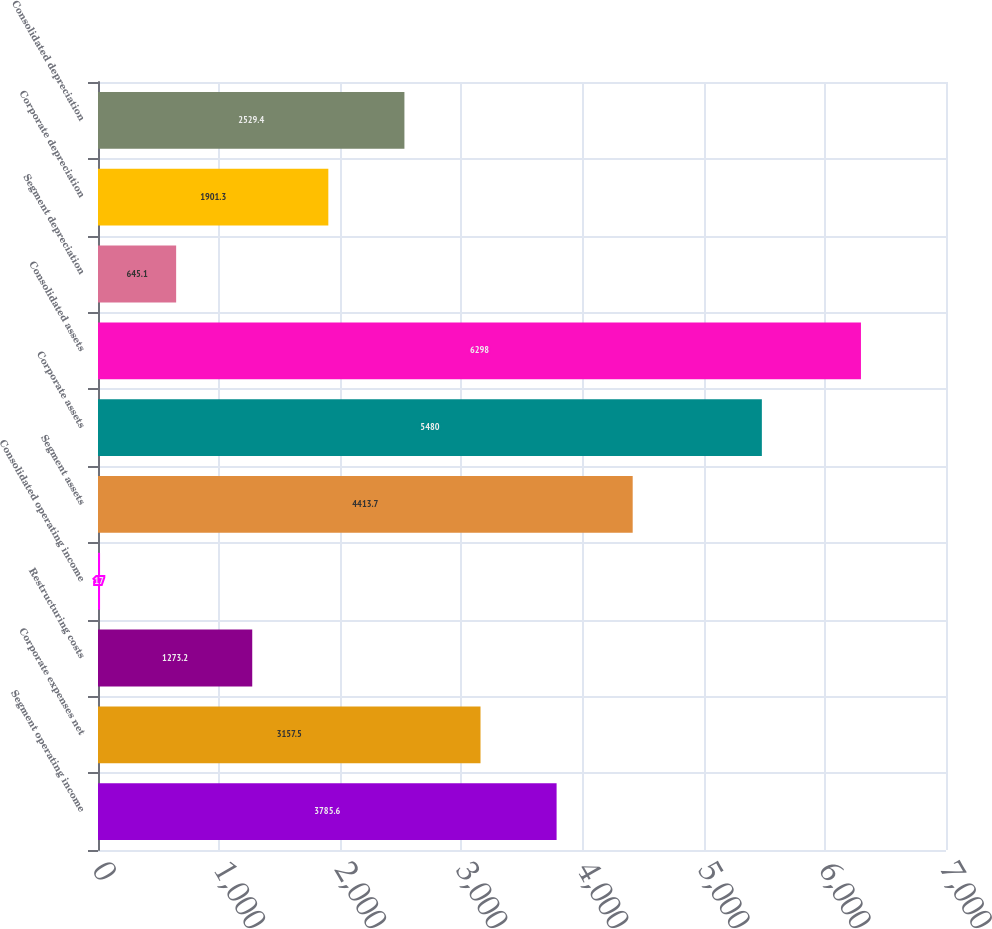Convert chart. <chart><loc_0><loc_0><loc_500><loc_500><bar_chart><fcel>Segment operating income<fcel>Corporate expenses net<fcel>Restructuring costs<fcel>Consolidated operating income<fcel>Segment assets<fcel>Corporate assets<fcel>Consolidated assets<fcel>Segment depreciation<fcel>Corporate depreciation<fcel>Consolidated depreciation<nl><fcel>3785.6<fcel>3157.5<fcel>1273.2<fcel>17<fcel>4413.7<fcel>5480<fcel>6298<fcel>645.1<fcel>1901.3<fcel>2529.4<nl></chart> 